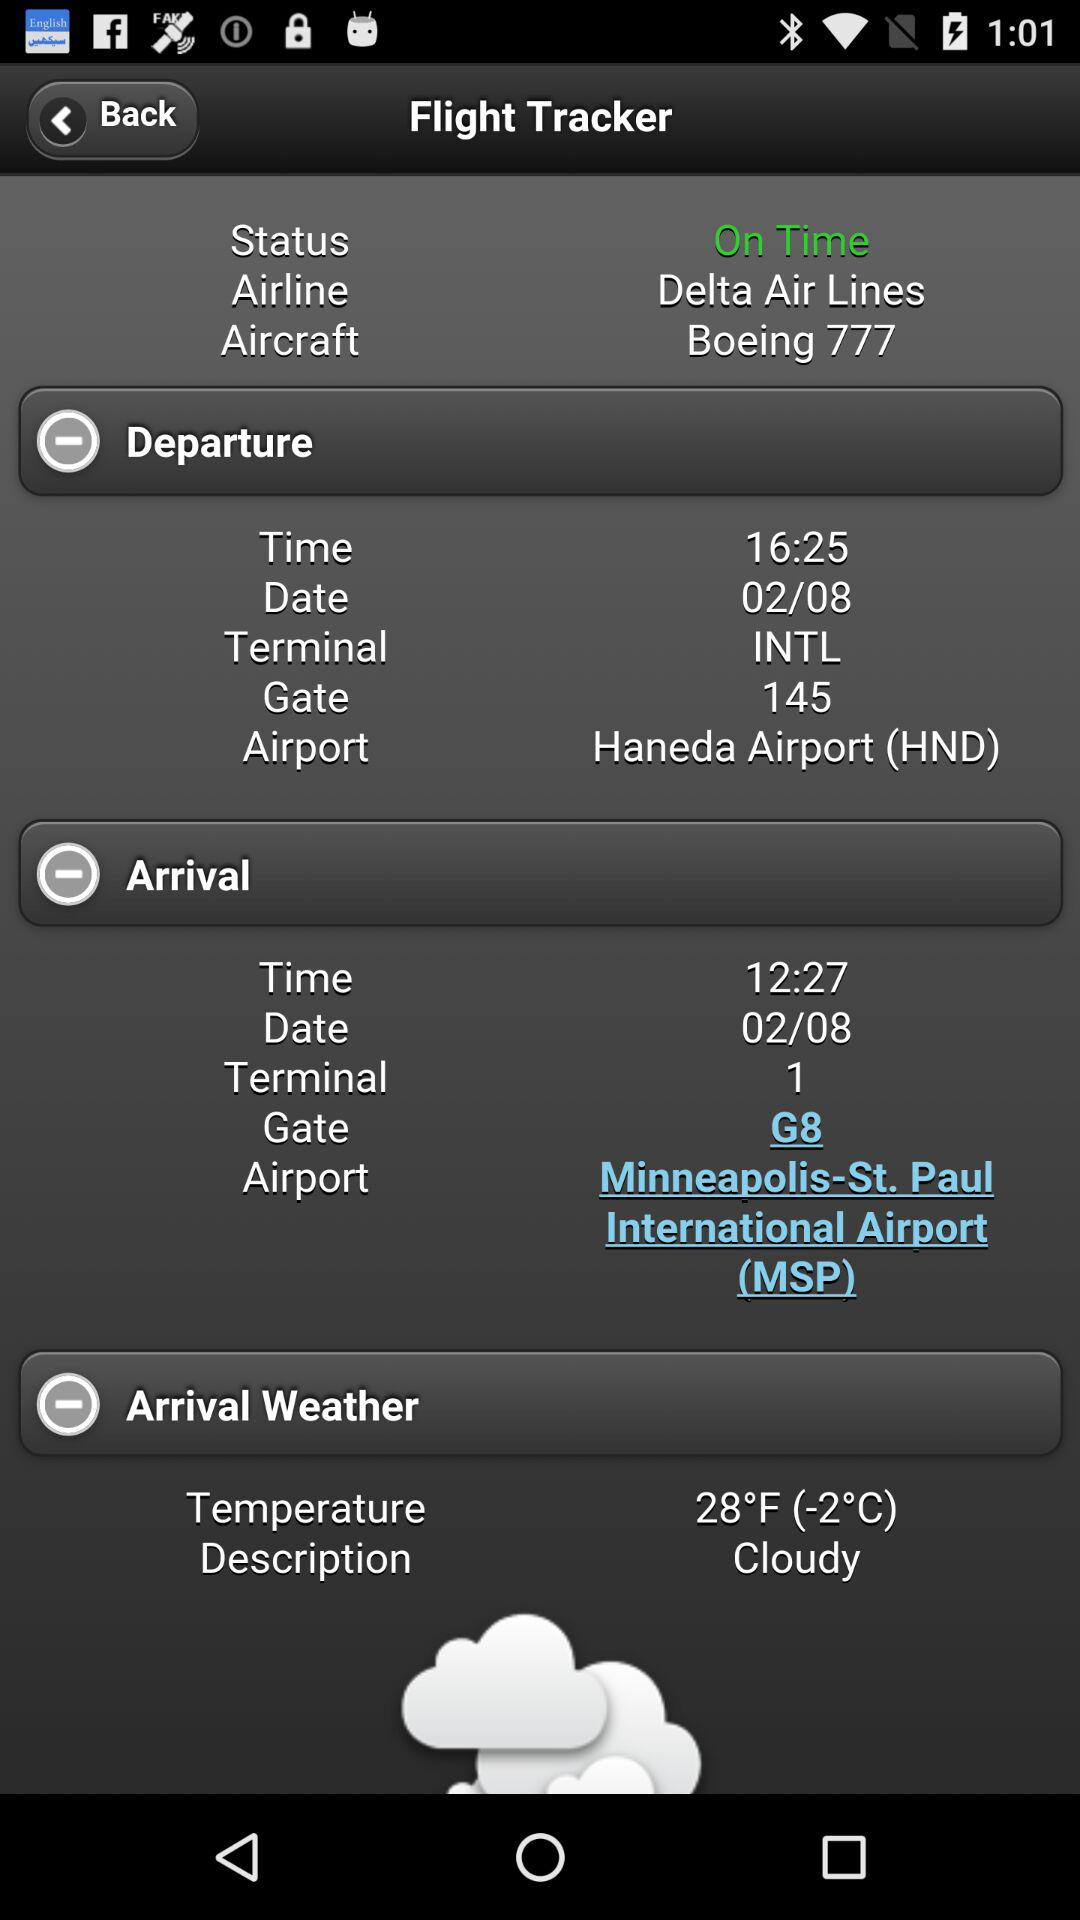What is the arrival date for the flight? The arrival date for the flight is February 8. 